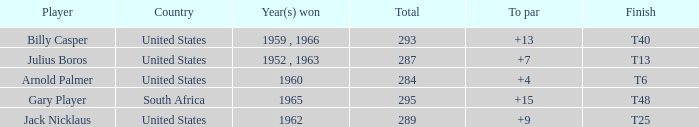Which player from the United States won in 1962? Jack Nicklaus. 